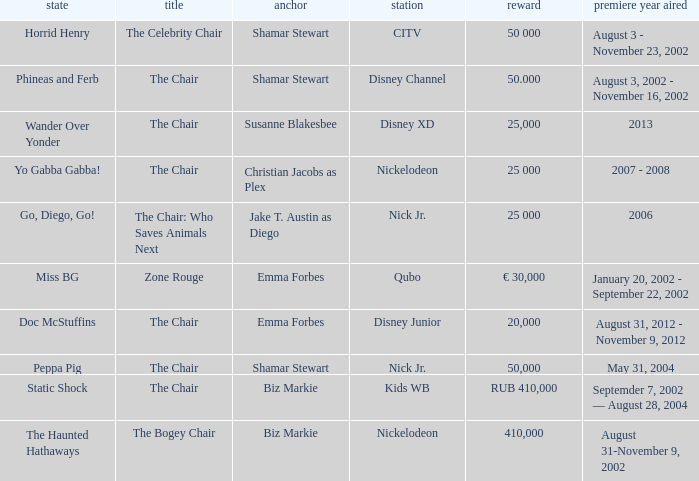What was the first year that had a prize of 50,000? May 31, 2004. 